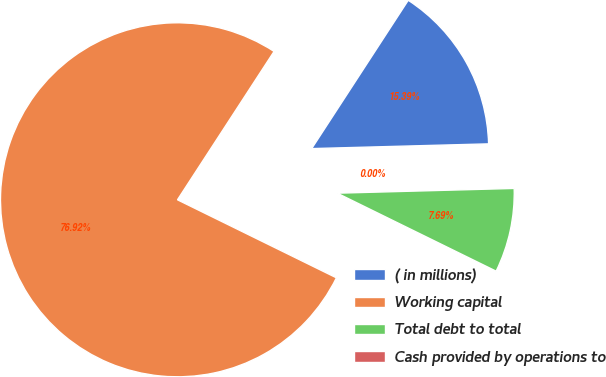Convert chart. <chart><loc_0><loc_0><loc_500><loc_500><pie_chart><fcel>( in millions)<fcel>Working capital<fcel>Total debt to total<fcel>Cash provided by operations to<nl><fcel>15.39%<fcel>76.92%<fcel>7.69%<fcel>0.0%<nl></chart> 